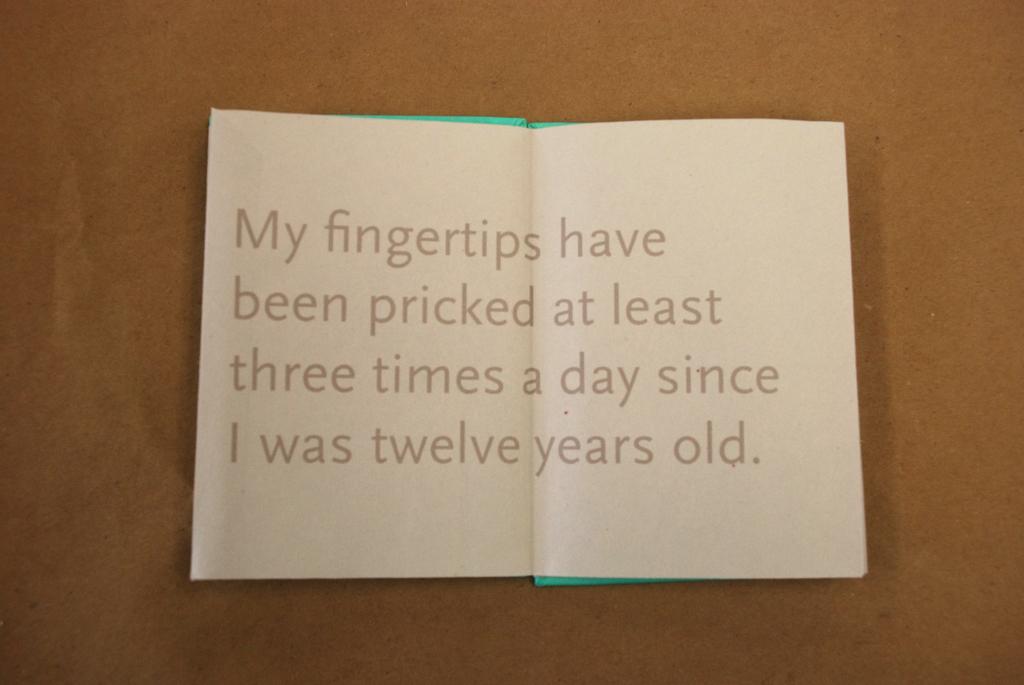What has been pricked?
Keep it short and to the point. Fingertips. Does having your fingers pricked mean you have diabetes?
Keep it short and to the point. Answering does not require reading text in the image. 